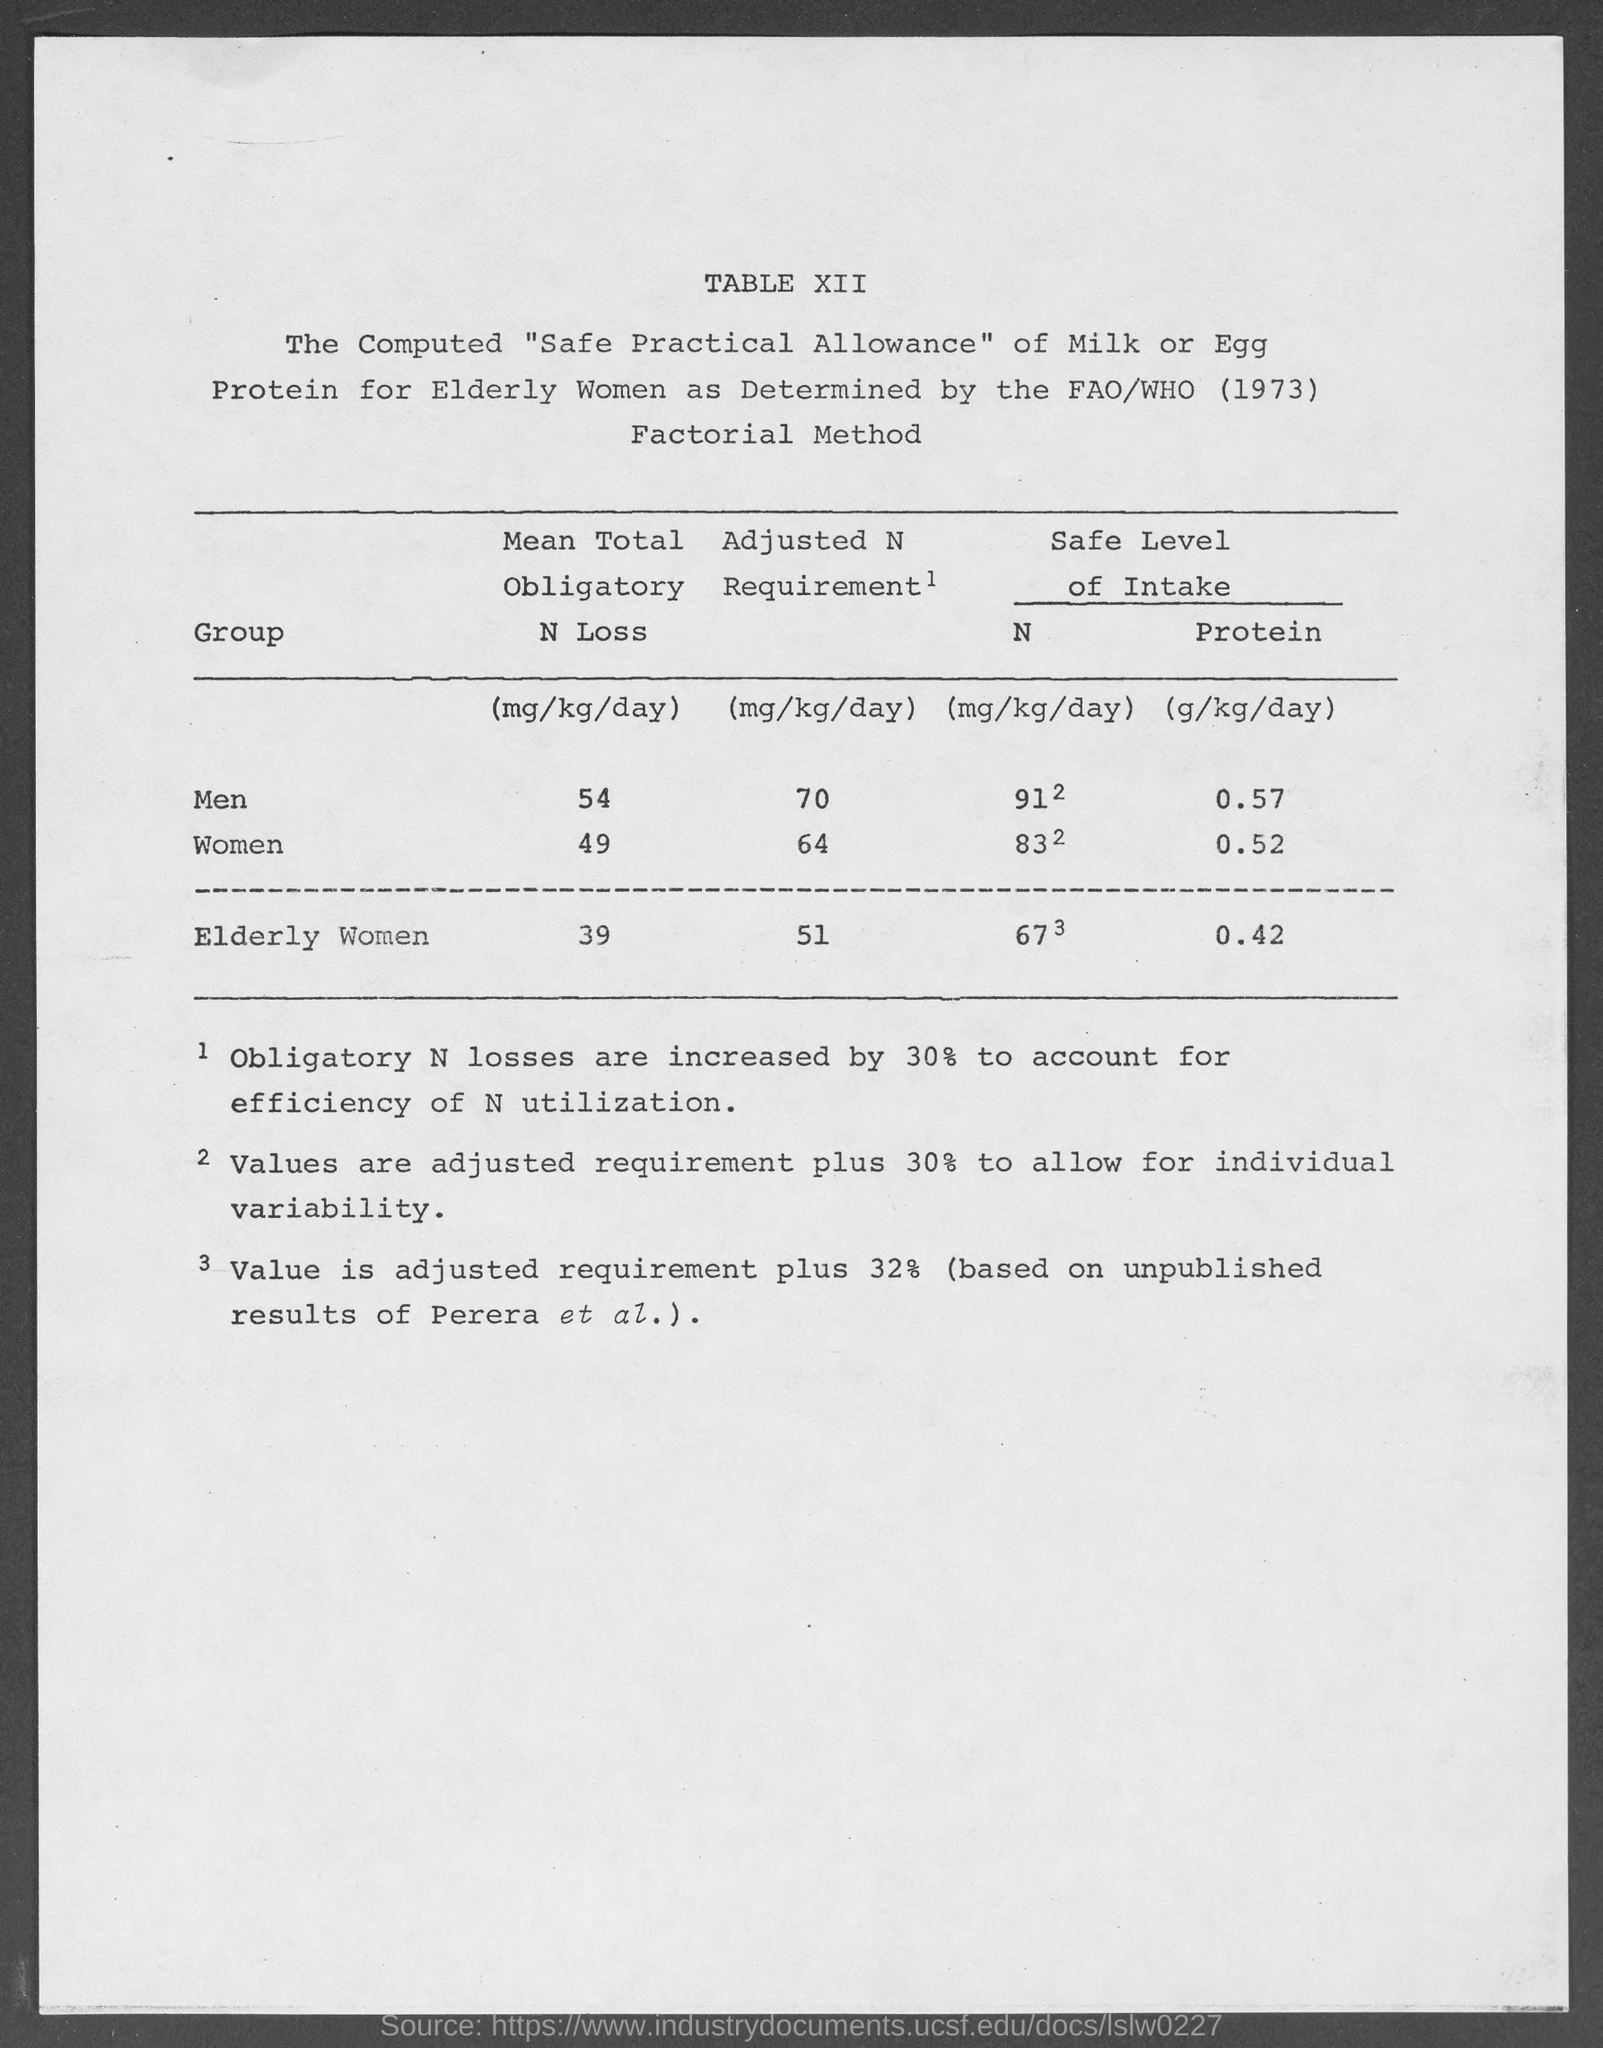What is the name of the method mentioned in the given page ?
Your answer should be very brief. Factorial method. What is the value of mean total obligatory n loss in men as mentioned in the given table ?
Your answer should be compact. 54. What is the value of mean total obligatory n loss in women as mentioned in the given table ?
Offer a very short reply. 49. What is the safe level intake of protein for men as mentioned in the given table ?
Ensure brevity in your answer.  0.57. What is the safe level intake of protein for women as mentioned in the given table ?
Make the answer very short. 0.52. What is the safe level intake of protein for elderly women as mentioned in the given table ?
Give a very brief answer. 0.42. 